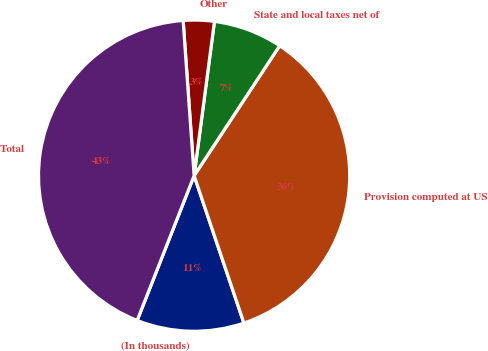Convert chart to OTSL. <chart><loc_0><loc_0><loc_500><loc_500><pie_chart><fcel>(In thousands)<fcel>Provision computed at US<fcel>State and local taxes net of<fcel>Other<fcel>Total<nl><fcel>11.15%<fcel>35.55%<fcel>7.18%<fcel>3.21%<fcel>42.91%<nl></chart> 